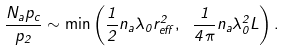Convert formula to latex. <formula><loc_0><loc_0><loc_500><loc_500>\frac { N _ { a } p _ { c } } { p _ { 2 } } \sim \min \left ( \frac { 1 } { 2 } n _ { a } \lambda _ { 0 } r _ { e f f } ^ { 2 } , \text { } \frac { 1 } { 4 \pi } n _ { a } \lambda _ { 0 } ^ { 2 } L \right ) .</formula> 